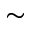<formula> <loc_0><loc_0><loc_500><loc_500>\sim</formula> 